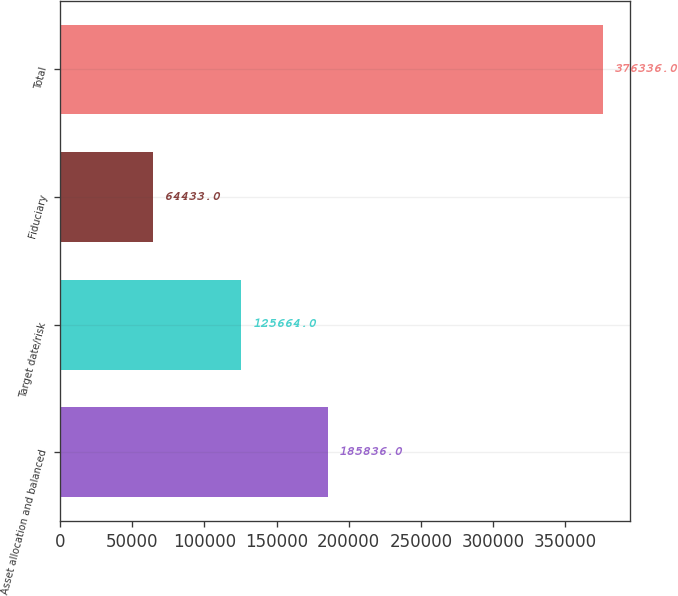Convert chart to OTSL. <chart><loc_0><loc_0><loc_500><loc_500><bar_chart><fcel>Asset allocation and balanced<fcel>Target date/risk<fcel>Fiduciary<fcel>Total<nl><fcel>185836<fcel>125664<fcel>64433<fcel>376336<nl></chart> 